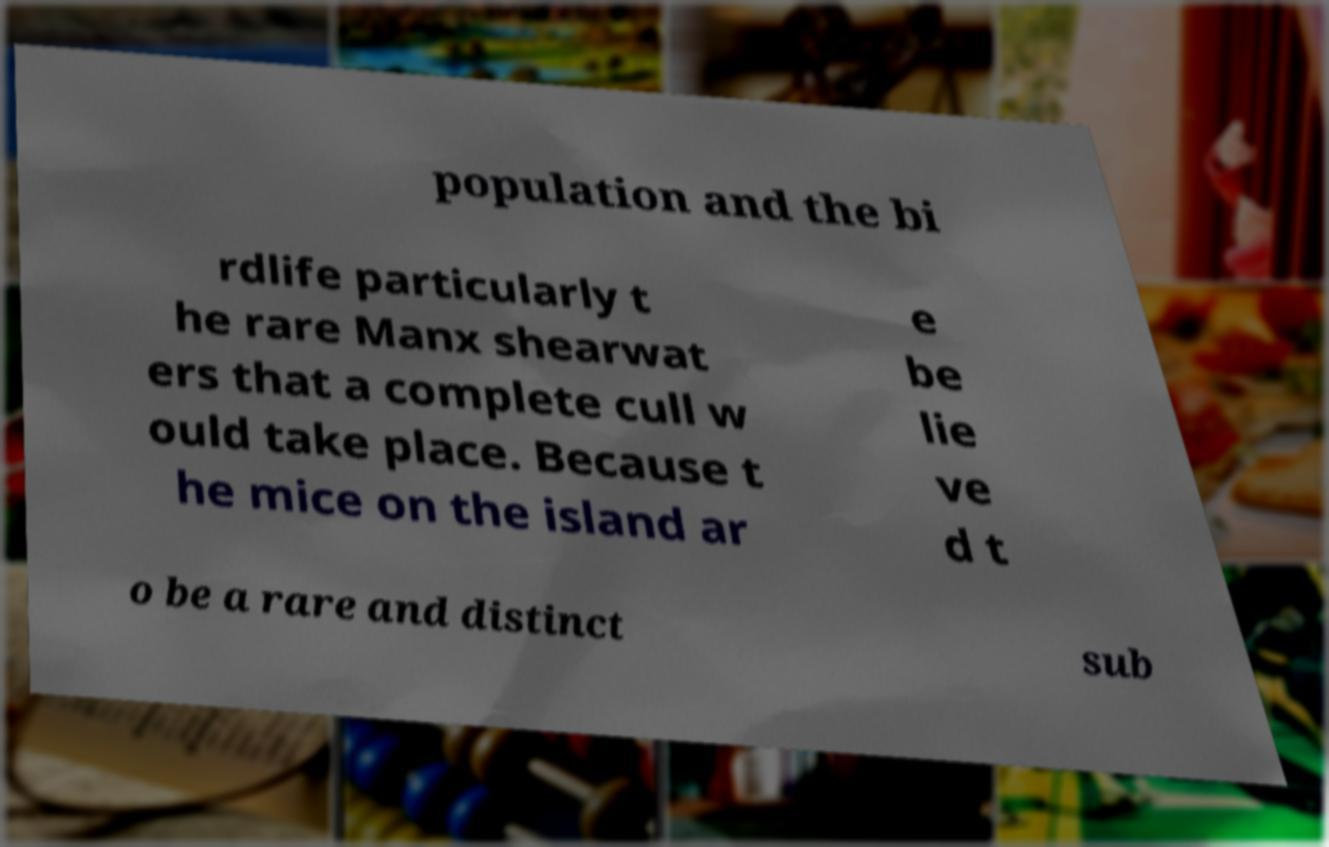What messages or text are displayed in this image? I need them in a readable, typed format. population and the bi rdlife particularly t he rare Manx shearwat ers that a complete cull w ould take place. Because t he mice on the island ar e be lie ve d t o be a rare and distinct sub 